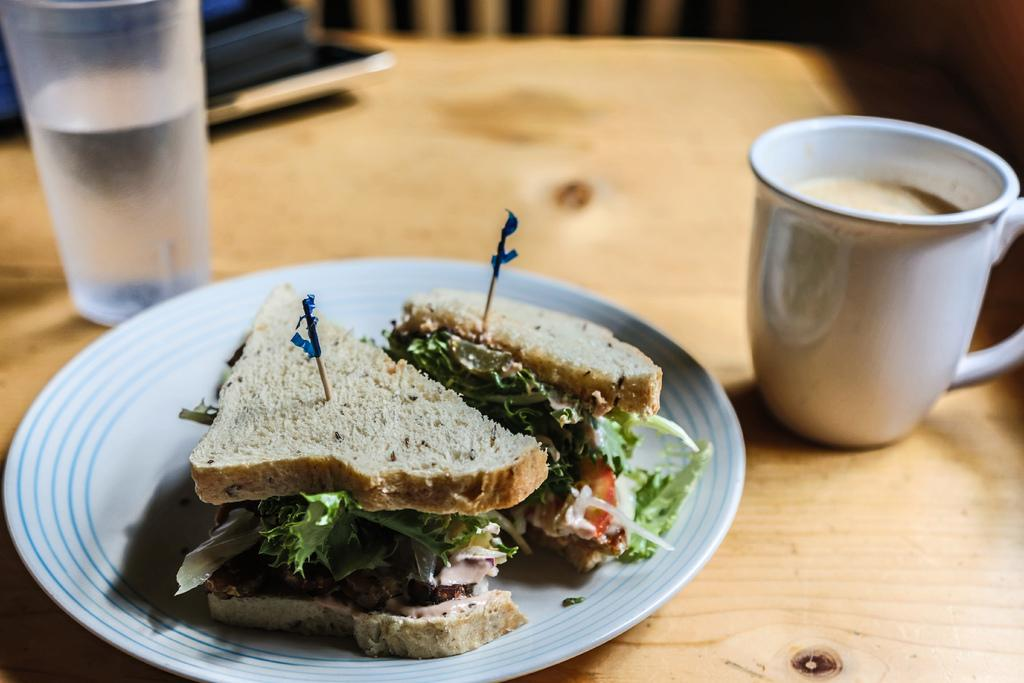What is the main object in the center of the image? There is a table in the center of the image. What can be seen on top of the table? There is a coffee mug, a glass, and a plate with food items on the table. Can you describe the food items on the plate? The food items on the plate are not specified in the facts provided. How many items are visible on the table? There are four items visible on the table: a coffee mug, a glass, and a plate with food items. What type of fruit is hanging from the tax in the image? There is no fruit or tax present in the image; it only features a table with a coffee mug, a glass, and a plate with food items. 